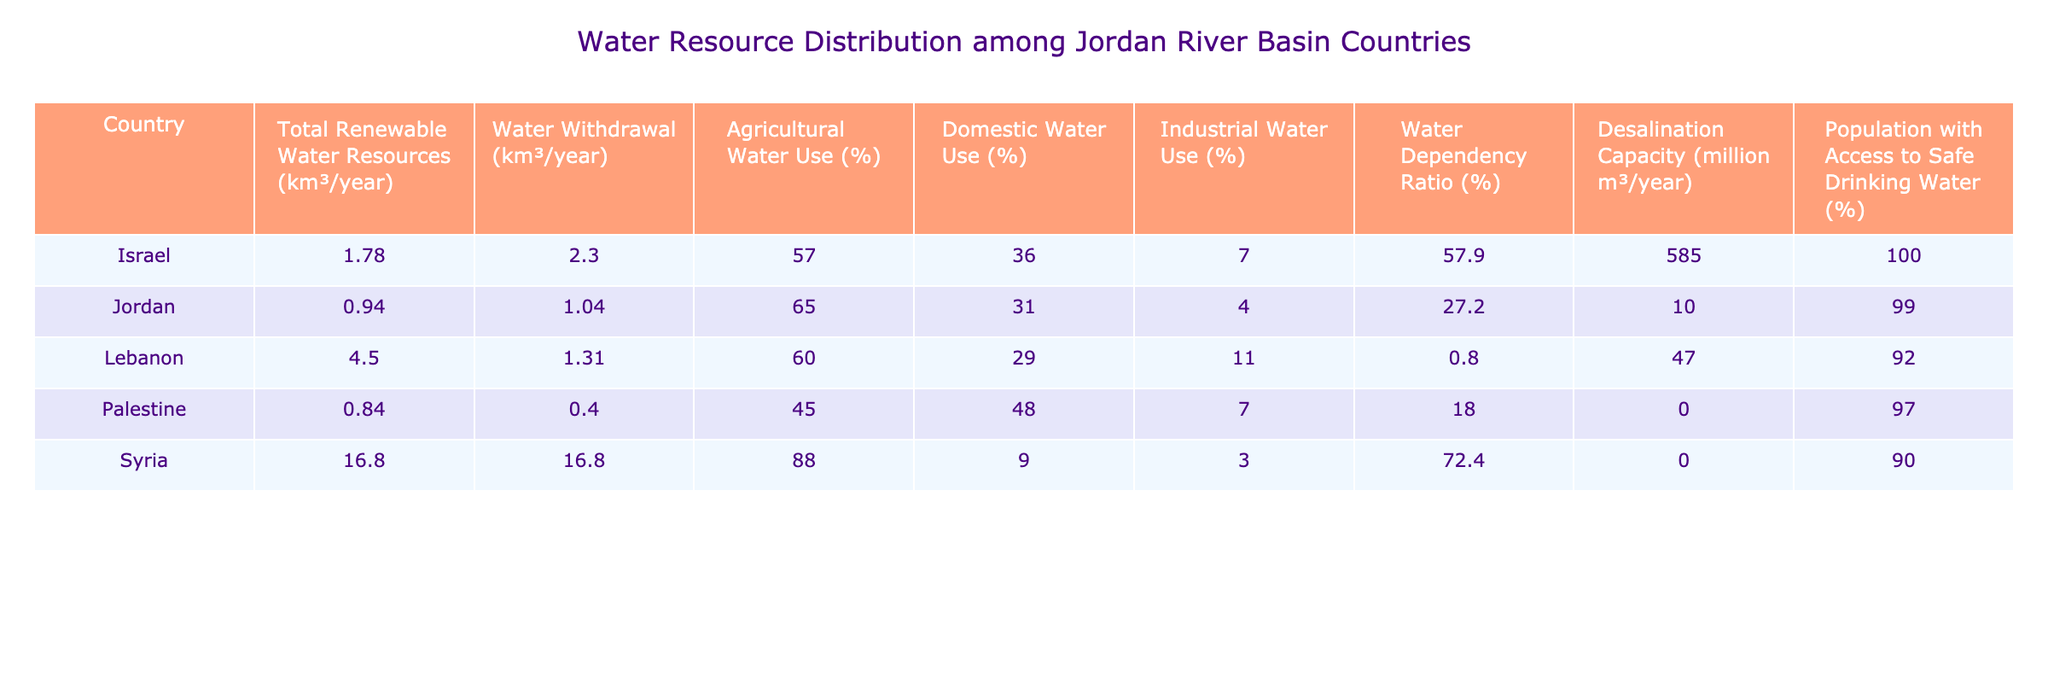What is the total renewable water resources of Syria? The table lists Syria's total renewable water resources as 16.8 km³/year.
Answer: 16.8 km³/year Which country has the highest water dependency ratio? The water dependency ratio is highest for Israel at 57.9%.
Answer: 57.9% What percentage of water withdrawal in Palestine is used for agricultural purposes? Palestine uses 45% of its water withdrawal for agricultural purposes, as shown in the table.
Answer: 45% Which countries have a desalination capacity of zero? According to the table, both Syria and Palestine have a desalination capacity of zero.
Answer: Syria and Palestine Calculate the average agricultural water use percentage among the countries listed. The agricultural water use percentages are 57, 65, 60, 45, 88. The sum is 315, and there are 5 countries, so the average is 315/5 = 63%.
Answer: 63% Is Jordan's domestic water use percentage higher than that of Lebanon? Jordan's domestic water use is 31%, whereas Lebanon's is 29%, so yes, Jordan's percentage is higher.
Answer: Yes What is the total water withdrawal for all countries combined in the table? The total water withdrawal is 2.3 + 1.04 + 1.31 + 0.4 + 16.8 = 21.85 km³/year.
Answer: 21.85 km³/year Which country has the lowest population with access to safe drinking water? Palestine has the lowest percentage with 97% of the population having access to safe drinking water.
Answer: 97% How does Israel's agricultural water use compare to that of Syria? Israel uses 57% for agriculture while Syria uses 88%, making Israel's use lower than Syria's.
Answer: Lower What is the total renewable water resources for Lebanon and Jordan combined? The total for Lebanon (4.5 km³/year) and Jordan (0.94 km³/year) is 4.5 + 0.94 = 5.44 km³/year.
Answer: 5.44 km³/year 